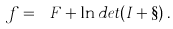<formula> <loc_0><loc_0><loc_500><loc_500>\ f = \ F + \ln d e t ( I + \S ) \, .</formula> 